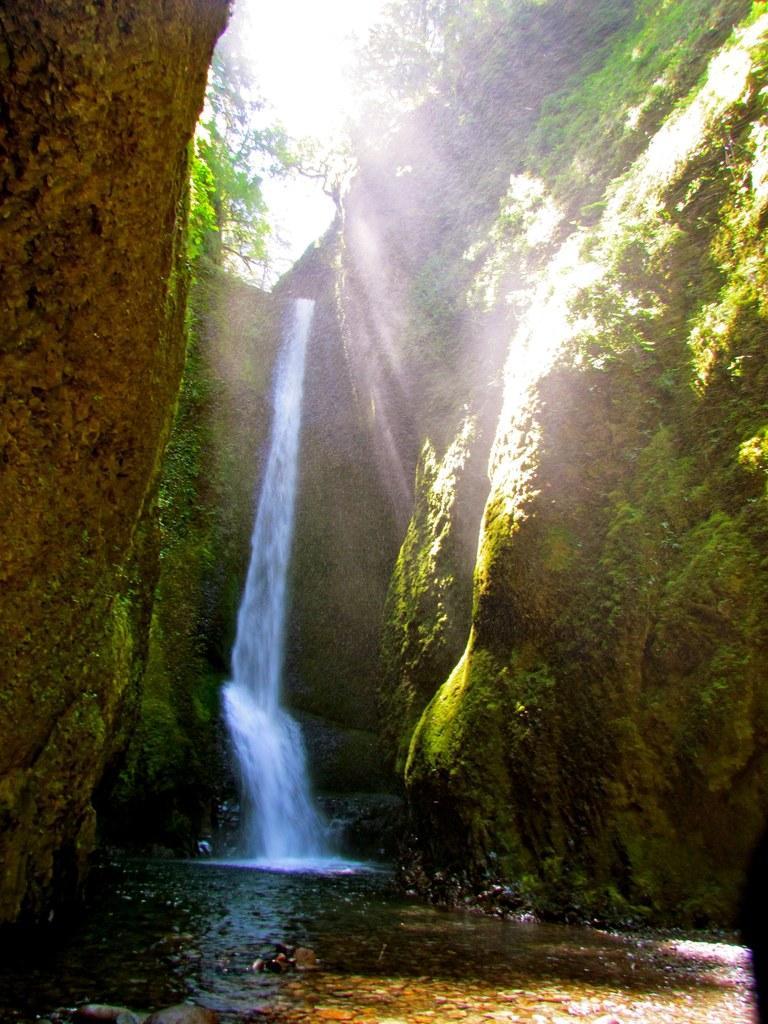Describe this image in one or two sentences. In this picture I can see water fall, rocks , trees, sky and the sunlight falling on the rocks. 